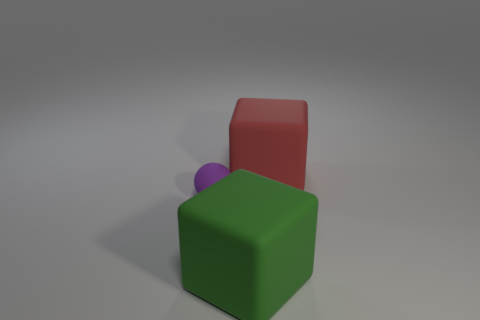Subtract all green cubes. How many cubes are left? 1 Subtract all blue spheres. How many green cubes are left? 1 Add 2 green things. How many objects exist? 5 Subtract all balls. How many objects are left? 2 Subtract 2 cubes. How many cubes are left? 0 Subtract all cyan spheres. Subtract all green cylinders. How many spheres are left? 1 Subtract all large objects. Subtract all red rubber blocks. How many objects are left? 0 Add 3 matte balls. How many matte balls are left? 4 Add 2 gray rubber blocks. How many gray rubber blocks exist? 2 Subtract 0 red cylinders. How many objects are left? 3 